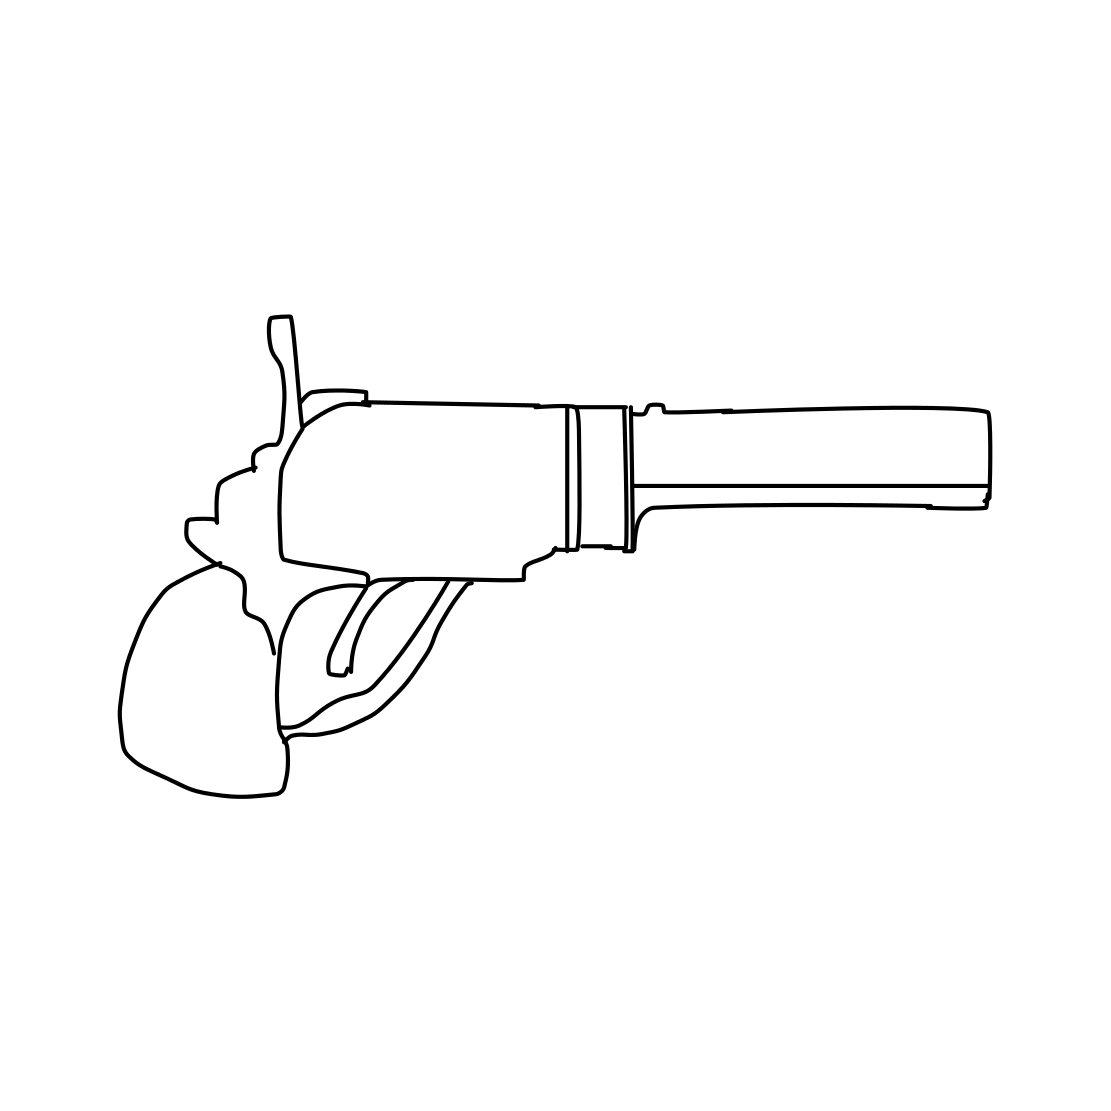Could you use this sketch as an educational tool? Certainly, this sketch could serve as an educational illustration, helping to explain the main parts of a revolver without the unnecessary detail that might complicate a beginner's understanding. What are the key parts that should be highlighted for education purposes? Key parts to focus on would include the barrel, the cylinder which holds the ammunition, the trigger which sets off the firing mechanism, and the grip which allows for handling. Additional terms like 'hammer' and 'ejector rod' could be introduced as the learner becomes more advanced. 